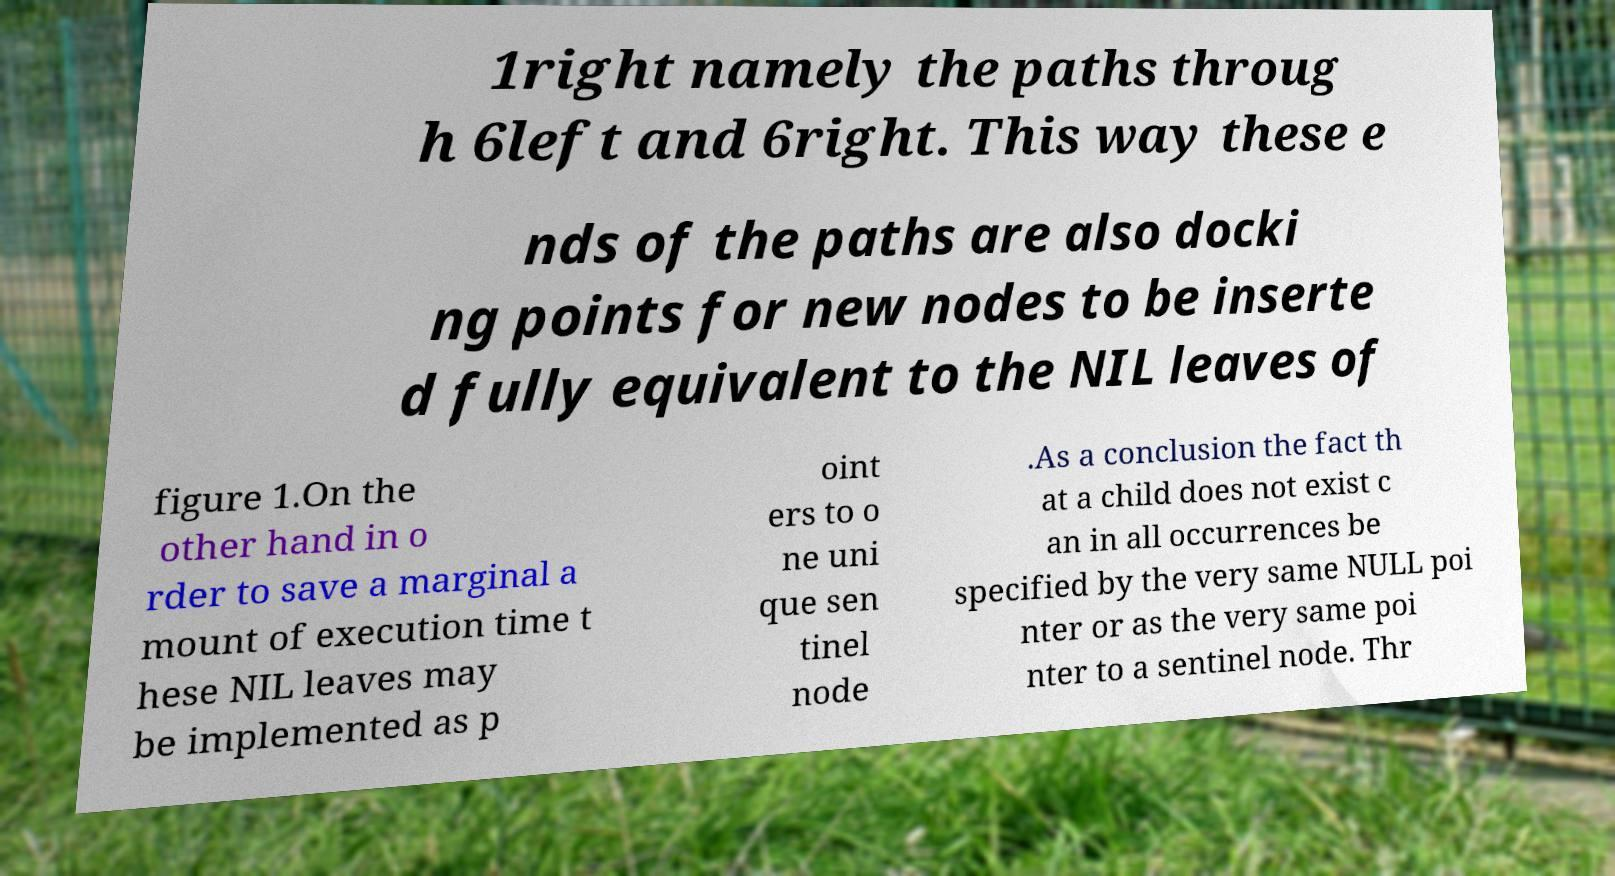For documentation purposes, I need the text within this image transcribed. Could you provide that? 1right namely the paths throug h 6left and 6right. This way these e nds of the paths are also docki ng points for new nodes to be inserte d fully equivalent to the NIL leaves of figure 1.On the other hand in o rder to save a marginal a mount of execution time t hese NIL leaves may be implemented as p oint ers to o ne uni que sen tinel node .As a conclusion the fact th at a child does not exist c an in all occurrences be specified by the very same NULL poi nter or as the very same poi nter to a sentinel node. Thr 